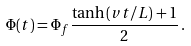<formula> <loc_0><loc_0><loc_500><loc_500>\Phi ( t ) = \Phi _ { f } \frac { \tanh { ( v t / L ) } + 1 } { 2 } \, .</formula> 